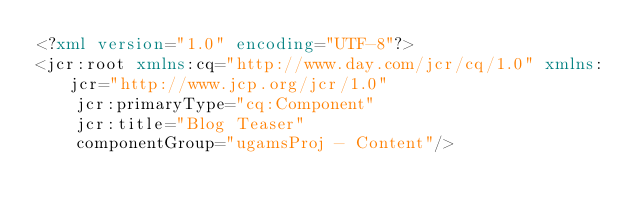<code> <loc_0><loc_0><loc_500><loc_500><_XML_><?xml version="1.0" encoding="UTF-8"?>
<jcr:root xmlns:cq="http://www.day.com/jcr/cq/1.0" xmlns:jcr="http://www.jcp.org/jcr/1.0"
    jcr:primaryType="cq:Component"
    jcr:title="Blog Teaser"
    componentGroup="ugamsProj - Content"/>
</code> 